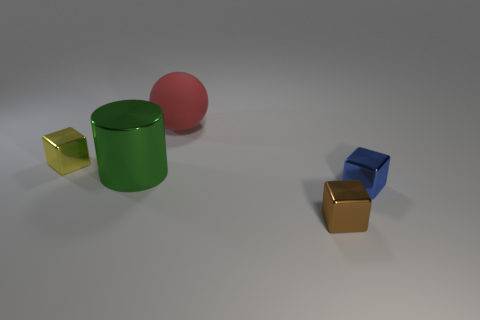Add 5 shiny things. How many objects exist? 10 Subtract all cylinders. How many objects are left? 4 Add 3 brown things. How many brown things exist? 4 Subtract 1 green cylinders. How many objects are left? 4 Subtract all large brown matte things. Subtract all big green shiny cylinders. How many objects are left? 4 Add 2 tiny yellow cubes. How many tiny yellow cubes are left? 3 